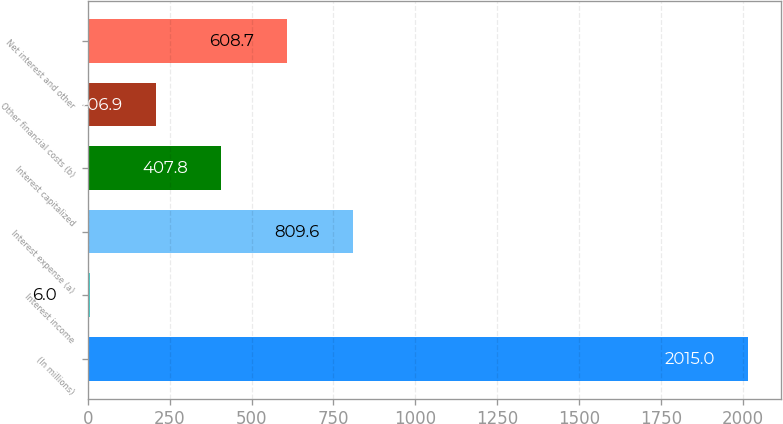Convert chart. <chart><loc_0><loc_0><loc_500><loc_500><bar_chart><fcel>(In millions)<fcel>Interest income<fcel>Interest expense (a)<fcel>Interest capitalized<fcel>Other financial costs (b)<fcel>Net interest and other<nl><fcel>2015<fcel>6<fcel>809.6<fcel>407.8<fcel>206.9<fcel>608.7<nl></chart> 